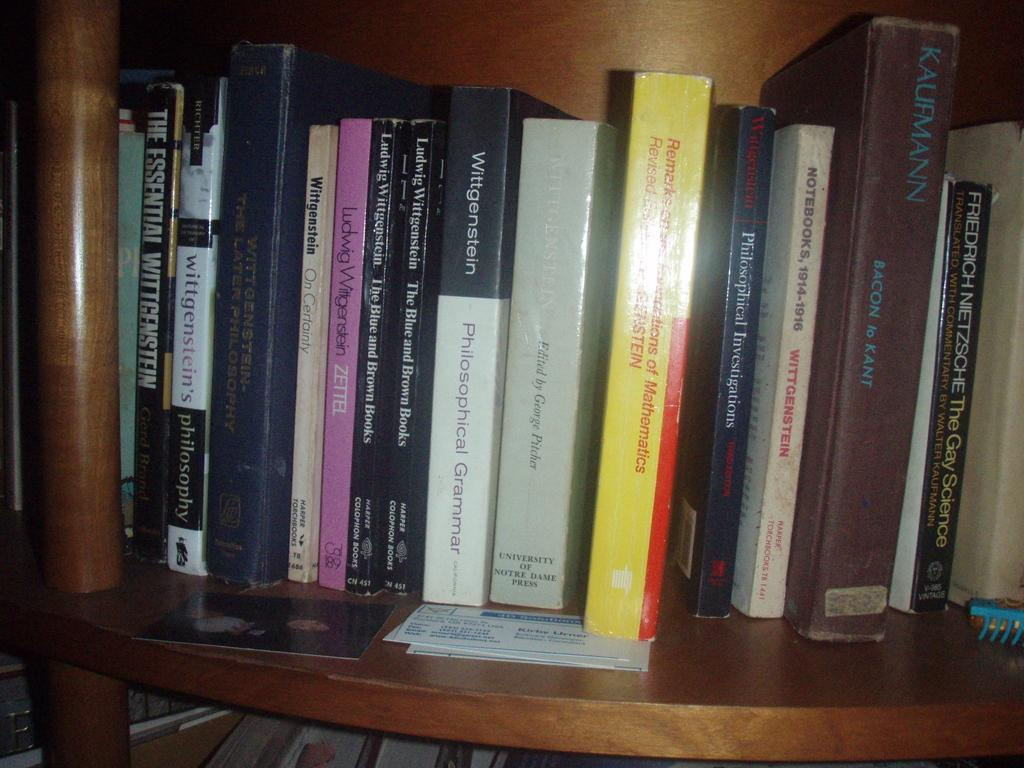<image>
Provide a brief description of the given image. A brown book with "Kaufmann" in blue letters on the spine sits on a shelf with other books. 